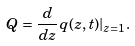<formula> <loc_0><loc_0><loc_500><loc_500>Q = \frac { d } { d z } q ( z , t ) | _ { z = 1 } .</formula> 